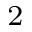Convert formula to latex. <formula><loc_0><loc_0><loc_500><loc_500>^ { 2 }</formula> 